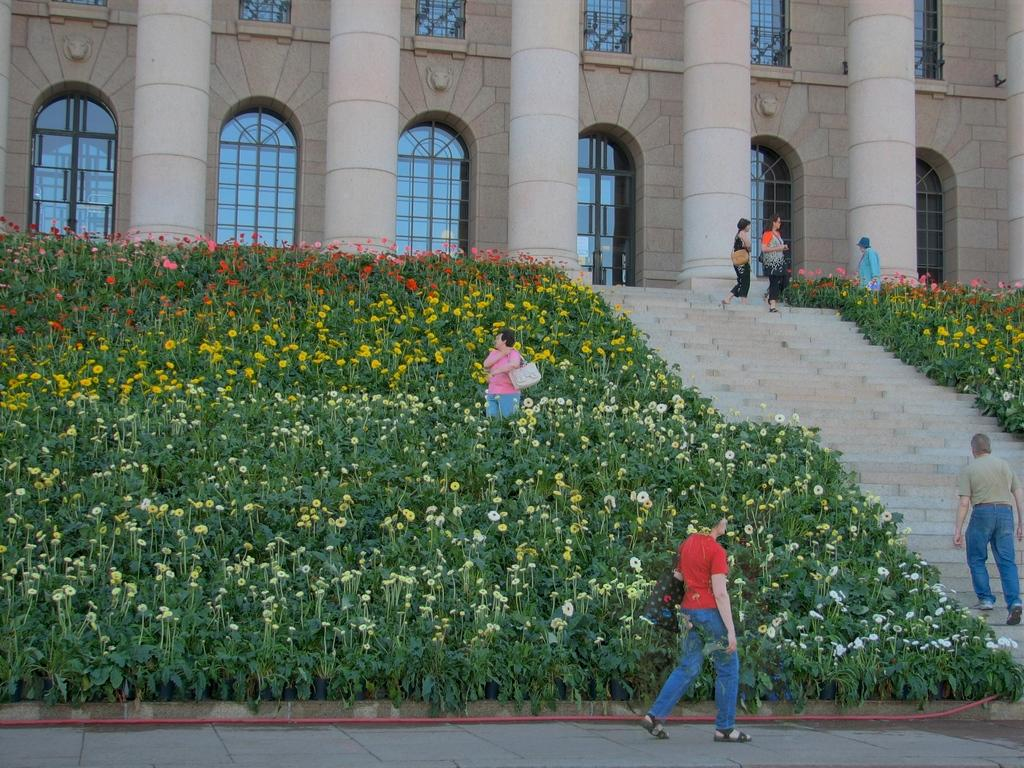What can be seen in the foreground of the image? In the foreground of the image, there is a fence, flowering plants, a group of people, and a staircase. What type of structure is visible in the image? There is a building wall in the image, along with pillars and windows. When was the image taken? The image was taken during the day. What type of treatment is being administered to the wheel in the image? There is no wheel present in the image, so no treatment can be administered to it. What form does the flower take in the image? The flowering plants in the image are not described in terms of their form, so we cannot determine the form of the flowers from the image. 